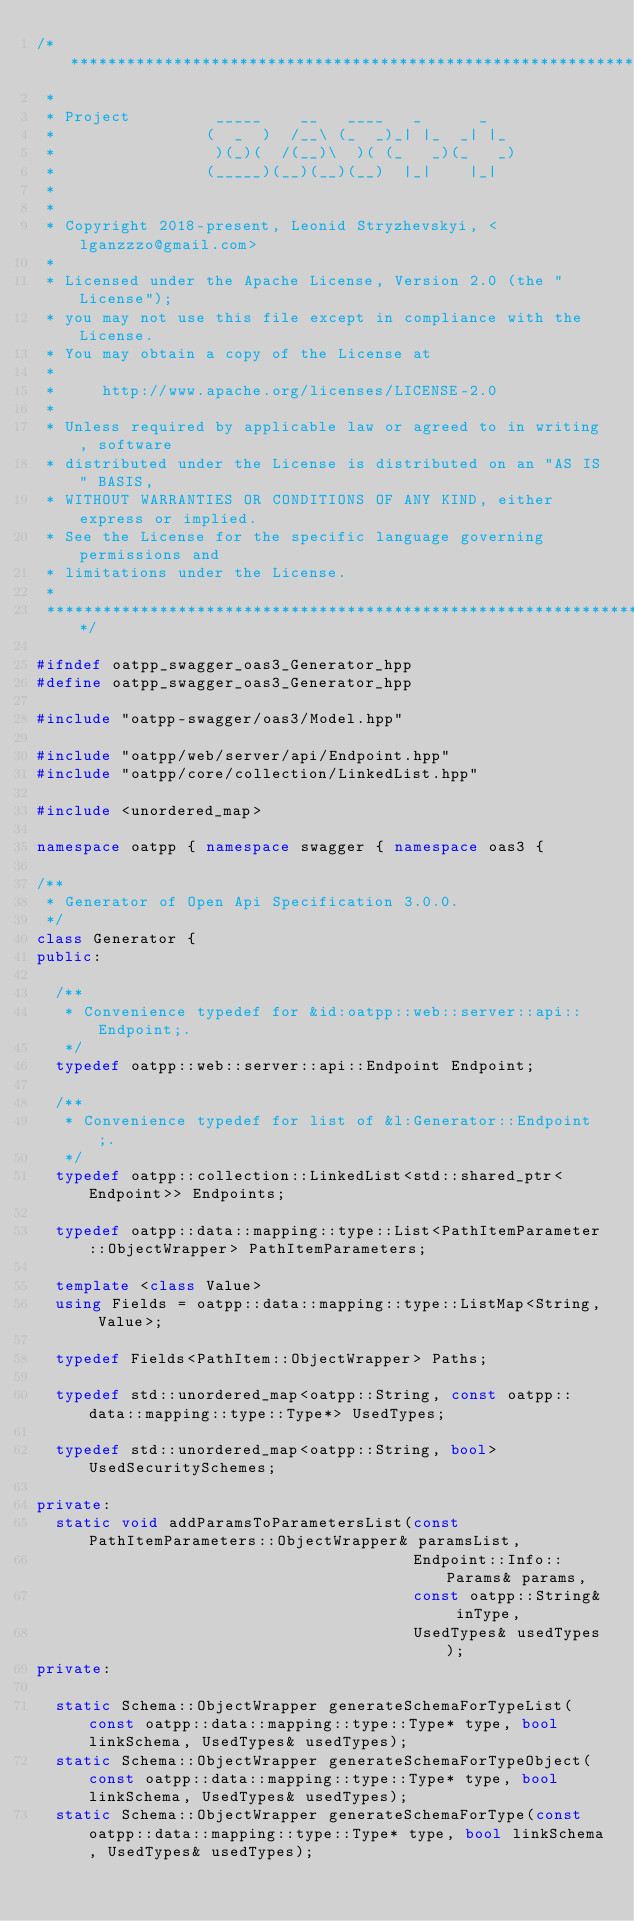Convert code to text. <code><loc_0><loc_0><loc_500><loc_500><_C++_>/***************************************************************************
 *
 * Project         _____    __   ____   _      _
 *                (  _  )  /__\ (_  _)_| |_  _| |_
 *                 )(_)(  /(__)\  )( (_   _)(_   _)
 *                (_____)(__)(__)(__)  |_|    |_|
 *
 *
 * Copyright 2018-present, Leonid Stryzhevskyi, <lganzzzo@gmail.com>
 *
 * Licensed under the Apache License, Version 2.0 (the "License");
 * you may not use this file except in compliance with the License.
 * You may obtain a copy of the License at
 *
 *     http://www.apache.org/licenses/LICENSE-2.0
 *
 * Unless required by applicable law or agreed to in writing, software
 * distributed under the License is distributed on an "AS IS" BASIS,
 * WITHOUT WARRANTIES OR CONDITIONS OF ANY KIND, either express or implied.
 * See the License for the specific language governing permissions and
 * limitations under the License.
 *
 ***************************************************************************/

#ifndef oatpp_swagger_oas3_Generator_hpp
#define oatpp_swagger_oas3_Generator_hpp

#include "oatpp-swagger/oas3/Model.hpp"

#include "oatpp/web/server/api/Endpoint.hpp"
#include "oatpp/core/collection/LinkedList.hpp"

#include <unordered_map>

namespace oatpp { namespace swagger { namespace oas3 {

/**
 * Generator of Open Api Specification 3.0.0.
 */
class Generator {
public:

  /**
   * Convenience typedef for &id:oatpp::web::server::api::Endpoint;.
   */
  typedef oatpp::web::server::api::Endpoint Endpoint;

  /**
   * Convenience typedef for list of &l:Generator::Endpoint;.
   */
  typedef oatpp::collection::LinkedList<std::shared_ptr<Endpoint>> Endpoints;

  typedef oatpp::data::mapping::type::List<PathItemParameter::ObjectWrapper> PathItemParameters;
  
  template <class Value>
  using Fields = oatpp::data::mapping::type::ListMap<String, Value>;
  
  typedef Fields<PathItem::ObjectWrapper> Paths;
  
  typedef std::unordered_map<oatpp::String, const oatpp::data::mapping::type::Type*> UsedTypes;

  typedef std::unordered_map<oatpp::String, bool> UsedSecuritySchemes;

private:
  static void addParamsToParametersList(const PathItemParameters::ObjectWrapper& paramsList,
                                        Endpoint::Info::Params& params,
                                        const oatpp::String& inType,
                                        UsedTypes& usedTypes);
private:

  static Schema::ObjectWrapper generateSchemaForTypeList(const oatpp::data::mapping::type::Type* type, bool linkSchema, UsedTypes& usedTypes);
  static Schema::ObjectWrapper generateSchemaForTypeObject(const oatpp::data::mapping::type::Type* type, bool linkSchema, UsedTypes& usedTypes);
  static Schema::ObjectWrapper generateSchemaForType(const oatpp::data::mapping::type::Type* type, bool linkSchema, UsedTypes& usedTypes);
</code> 